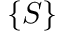Convert formula to latex. <formula><loc_0><loc_0><loc_500><loc_500>\{ S \}</formula> 